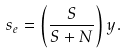<formula> <loc_0><loc_0><loc_500><loc_500>s _ { e } = \left ( \frac { S } { S + N } \right ) y .</formula> 